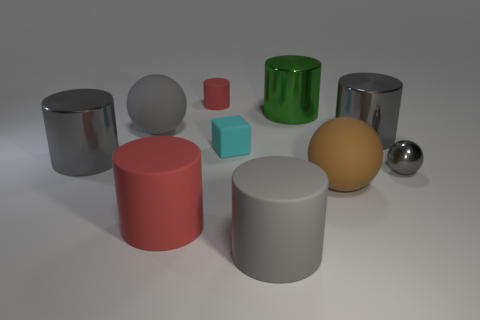How many gray cylinders must be subtracted to get 1 gray cylinders? 2 Subtract all red balls. How many gray cylinders are left? 3 Subtract all big brown rubber balls. How many balls are left? 2 Subtract 4 cylinders. How many cylinders are left? 2 Subtract all red cylinders. How many cylinders are left? 4 Subtract all green balls. Subtract all gray cubes. How many balls are left? 3 Subtract all spheres. How many objects are left? 7 Add 6 small cylinders. How many small cylinders are left? 7 Add 7 tiny purple metal cylinders. How many tiny purple metal cylinders exist? 7 Subtract 0 blue cylinders. How many objects are left? 10 